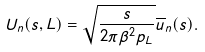Convert formula to latex. <formula><loc_0><loc_0><loc_500><loc_500>U _ { n } ( s , L ) = \sqrt { \frac { s } { 2 \pi \beta ^ { 2 } p _ { L } } } \overline { u } _ { n } ( s ) .</formula> 